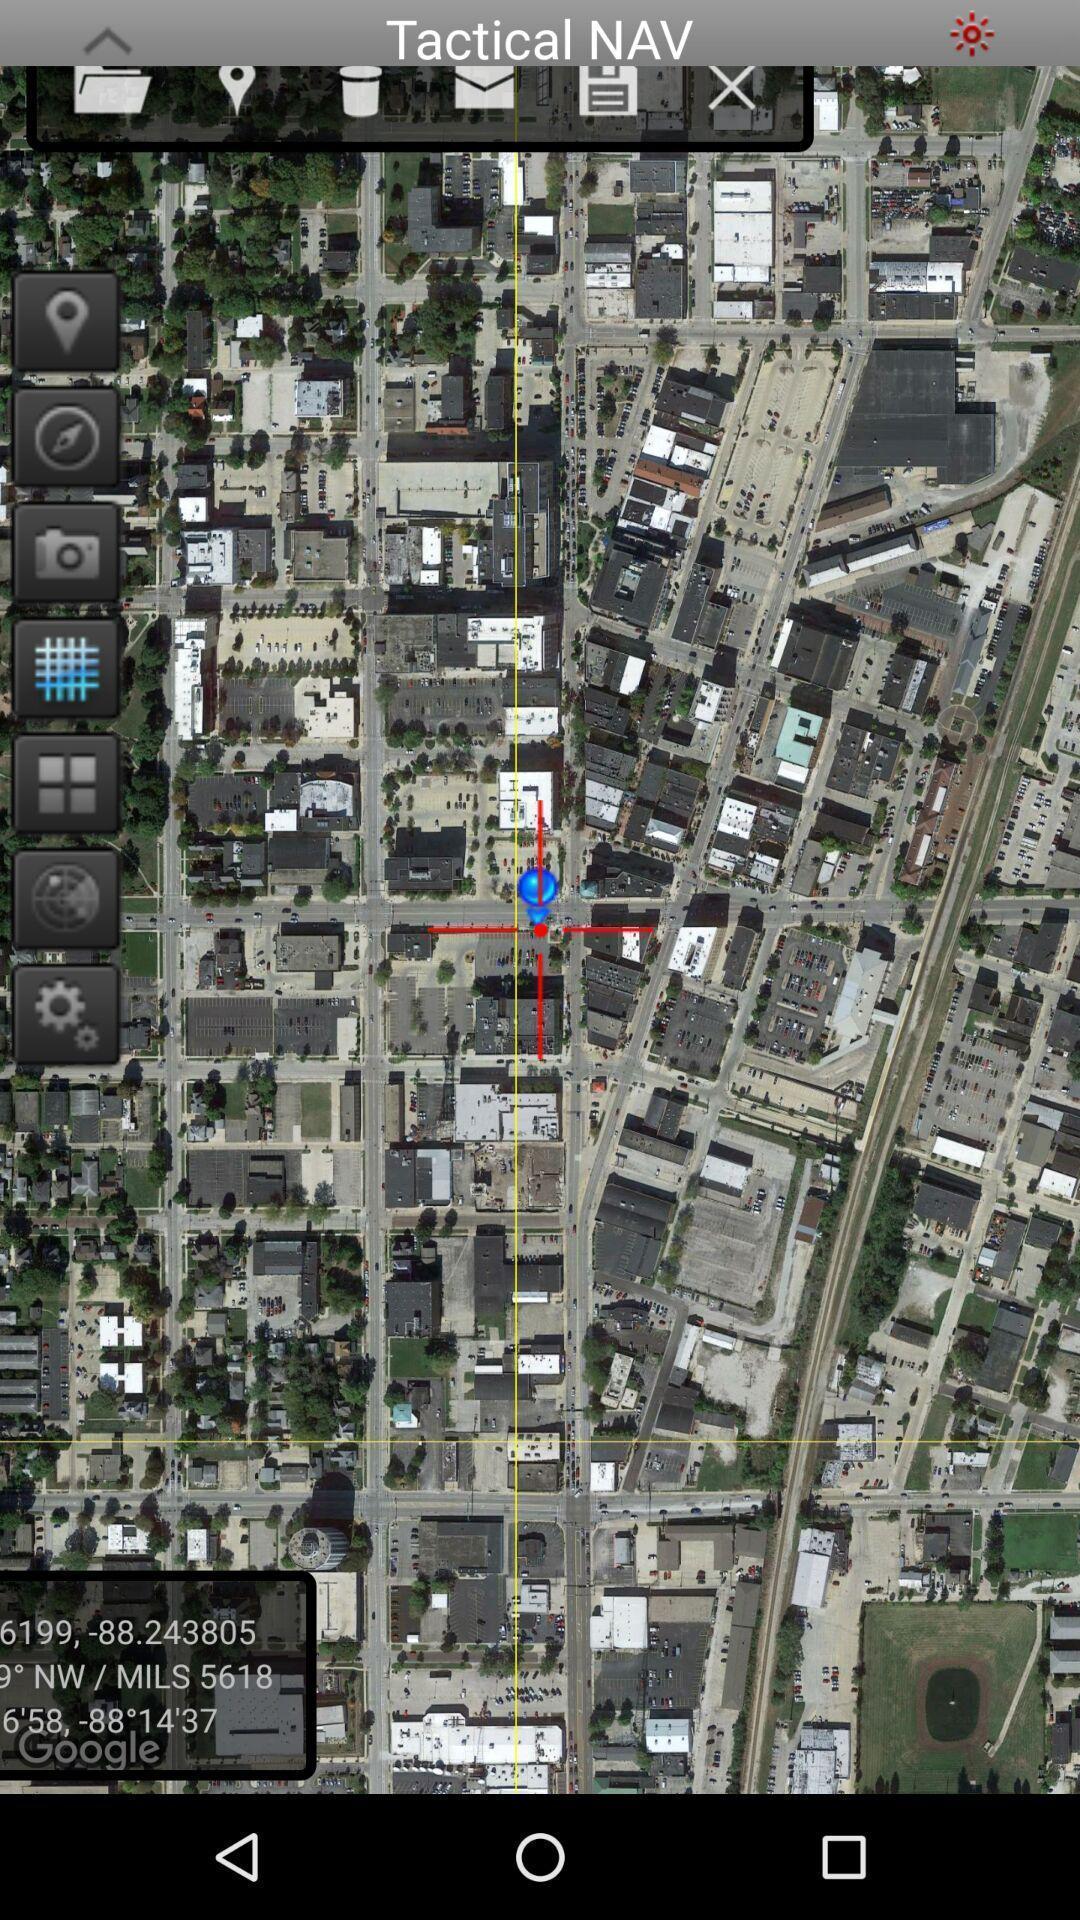Please provide a description for this image. Screen shows location with multiple options. 